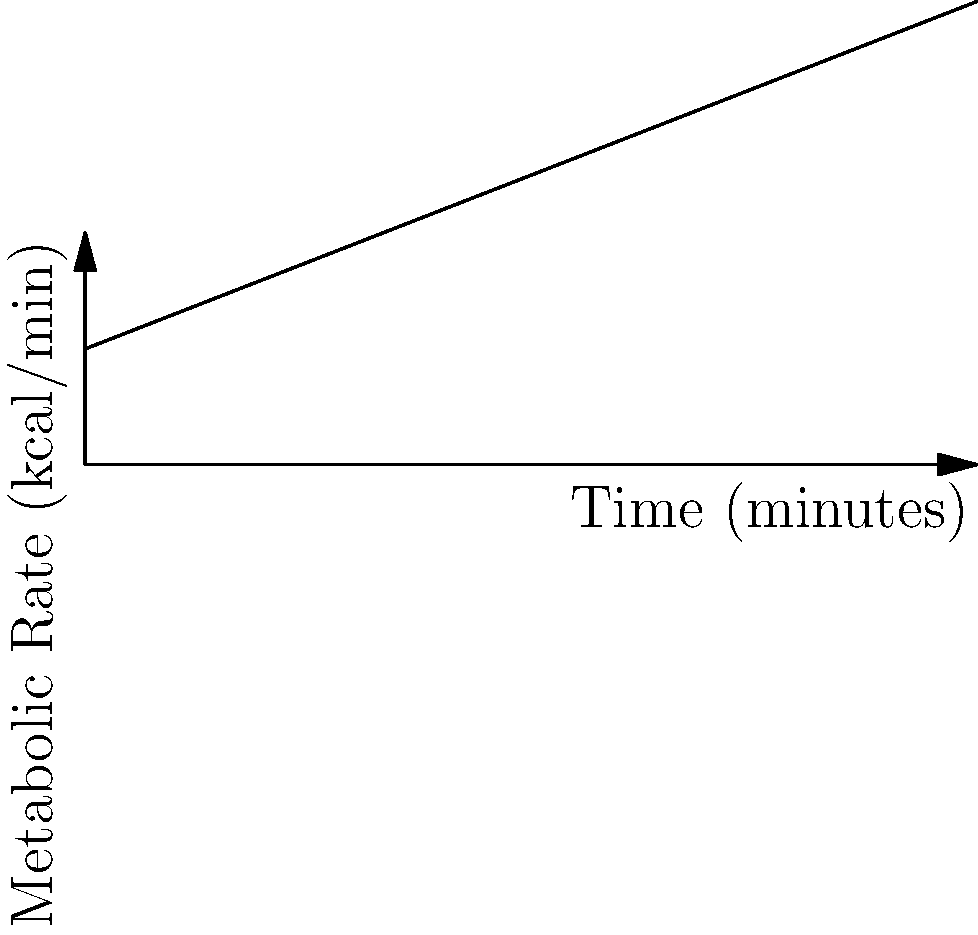A runner's metabolic rate during a 60-minute run is shown in the graph above. Estimate the total number of calories burned during this run. To estimate the total number of calories burned, we need to calculate the area under the curve. The graph shows a linear increase in metabolic rate over time.

Steps:
1. Identify the initial and final metabolic rates:
   - Initial rate (at 0 minutes): 10 kcal/min
   - Final rate (at 60 minutes): 20 kcal/min

2. Calculate the average metabolic rate:
   $\text{Average rate} = \frac{\text{Initial rate} + \text{Final rate}}{2} = \frac{10 + 20}{2} = 15 \text{ kcal/min}$

3. Calculate the total calories burned:
   $\text{Total calories} = \text{Average rate} \times \text{Time}$
   $\text{Total calories} = 15 \text{ kcal/min} \times 60 \text{ min} = 900 \text{ kcal}$

The total number of calories burned during the 60-minute run is approximately 900 kcal.
Answer: 900 kcal 